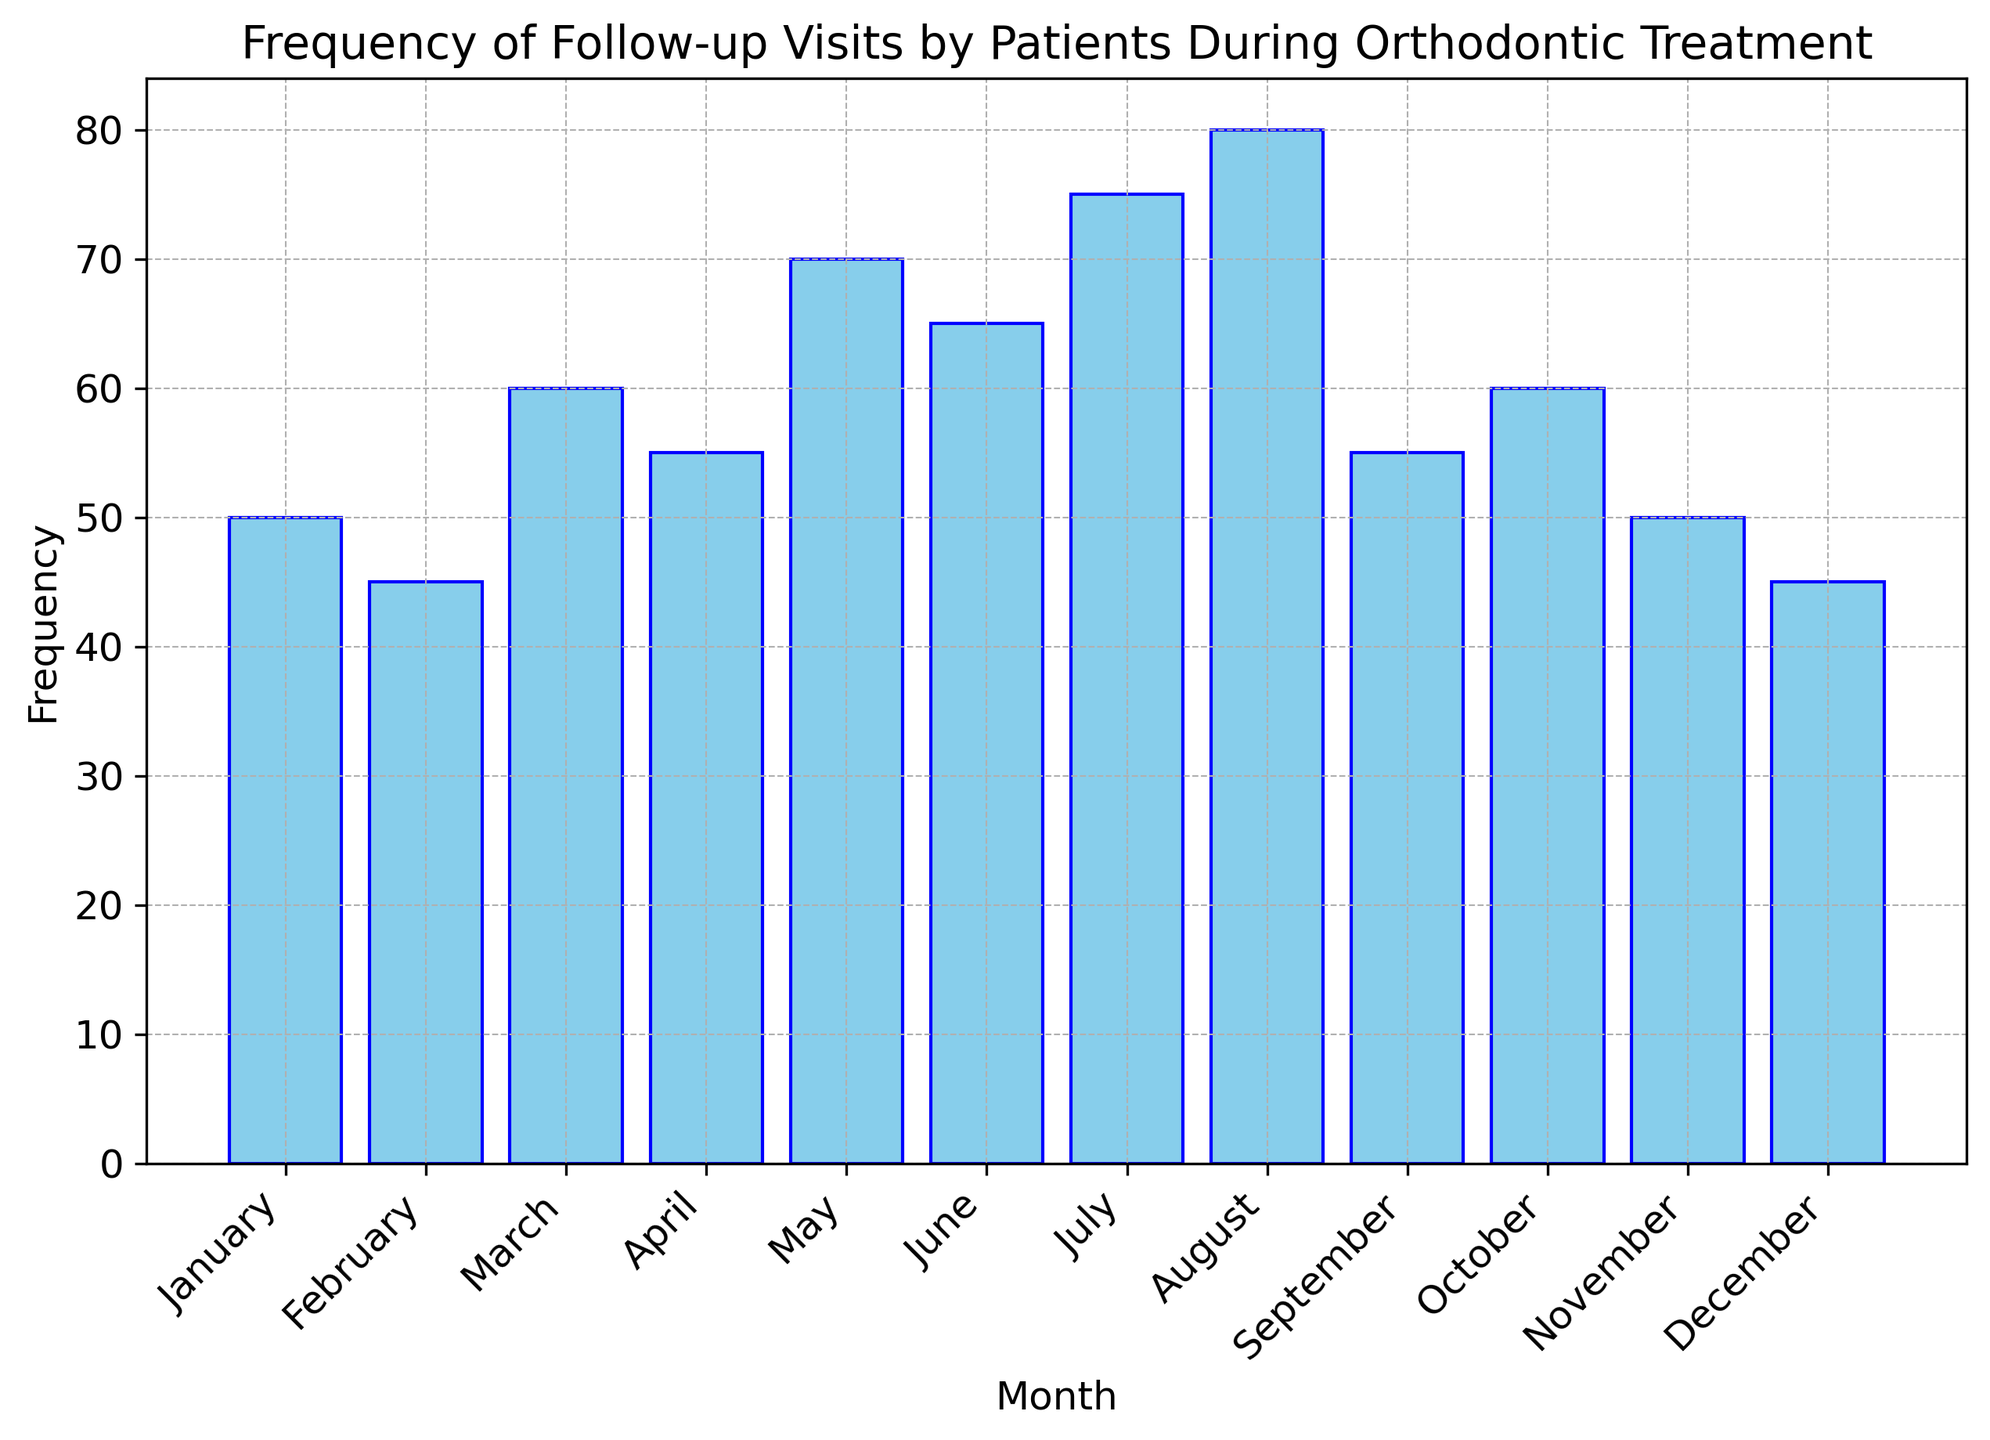Which month has the highest frequency of follow-up visits? By looking at the bar chart, we observe that the bar for August is the tallest, indicating the highest frequency.
Answer: August Which month has the lowest frequency of follow-up visits? From the bar chart, the bars for February and December are the shortest. Both have the same height, which shows the lowest frequency.
Answer: February and December What is the total frequency of follow-up visits for the first quarter of the year? The first quarter includes January, February, and March. Add the frequencies for these months: 50 (January) + 45 (February) + 60 (March) = 155.
Answer: 155 How much higher is the frequency of follow-up visits in July compared to April? The frequency for July is 75 and for April is 55. Subtract the frequency in April from the frequency in July: 75 - 55 = 20.
Answer: 20 Which months have a frequency of follow-up visits equal to 50? From the bar chart, we see that both January and November have bars at the height corresponding to the frequency of 50.
Answer: January and November What is the average frequency of follow-up visits in the summer months (June, July, and August)? To find the average, add the frequencies for June, July, and August, and then divide by 3: (65 + 75 + 80) / 3 = 220 / 3 ≈ 73.33.
Answer: 73.33 Compare the frequency of follow-up visits in March and October. Are they identical? By observing the bars for March and October, we see that both have the same height, indicating the same frequency of 60.
Answer: Yes, they are identical By how much does the frequency of follow-up visits in August exceed the frequency in February? The frequency for August is 80, while for February it is 45. Subtract the frequency in February from that in August: 80 - 45 = 35.
Answer: 35 Which month has a greater frequency: June or September? By comparing the height of the bars for June and September, we can see that June (65) has a greater frequency than September (55).
Answer: June What is the average frequency for the months with less than 60 visits? First, identify the months with less than 60 visits: January (50), February (45), April (55), September (55), November (50), and December (45). Sum these frequencies: 50 + 45 + 55 + 55 + 50 + 45 = 300; then divide by the number of months, which is 6: 300 / 6 = 50.
Answer: 50 